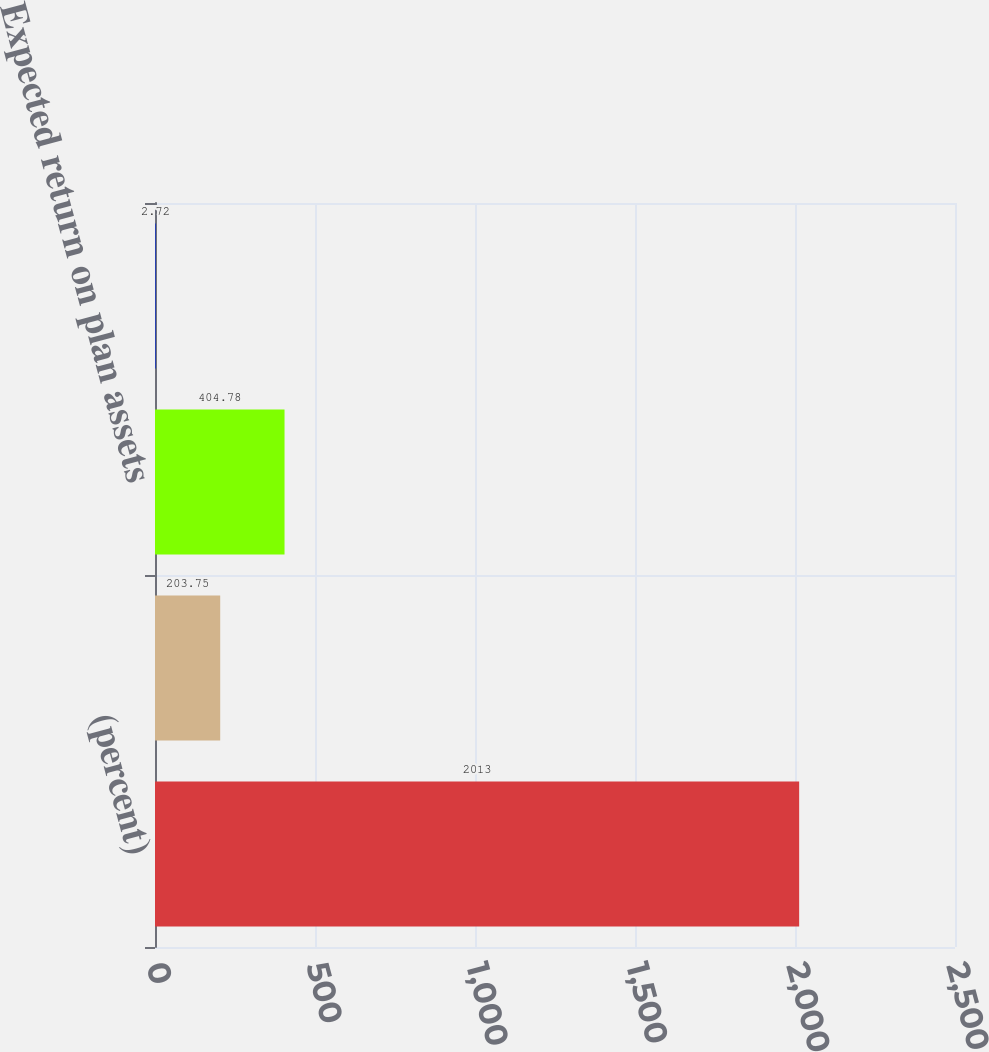<chart> <loc_0><loc_0><loc_500><loc_500><bar_chart><fcel>(percent)<fcel>Discount rate<fcel>Expected return on plan assets<fcel>Rate of compensation increase<nl><fcel>2013<fcel>203.75<fcel>404.78<fcel>2.72<nl></chart> 